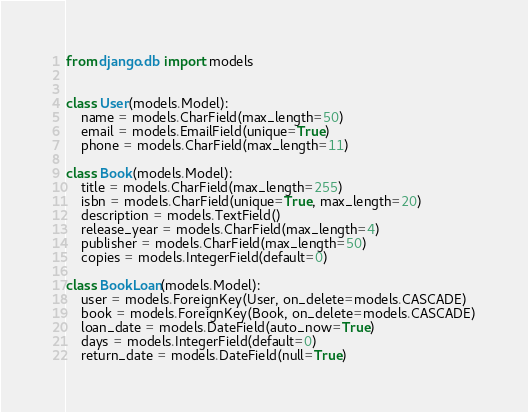<code> <loc_0><loc_0><loc_500><loc_500><_Python_>from django.db import models


class User(models.Model):
    name = models.CharField(max_length=50)
    email = models.EmailField(unique=True)
    phone = models.CharField(max_length=11)

class Book(models.Model):
    title = models.CharField(max_length=255)
    isbn = models.CharField(unique=True, max_length=20)
    description = models.TextField()
    release_year = models.CharField(max_length=4)
    publisher = models.CharField(max_length=50)
    copies = models.IntegerField(default=0)

class BookLoan(models.Model):
	user = models.ForeignKey(User, on_delete=models.CASCADE)
	book = models.ForeignKey(Book, on_delete=models.CASCADE)
	loan_date = models.DateField(auto_now=True)
	days = models.IntegerField(default=0)
	return_date = models.DateField(null=True)

</code> 